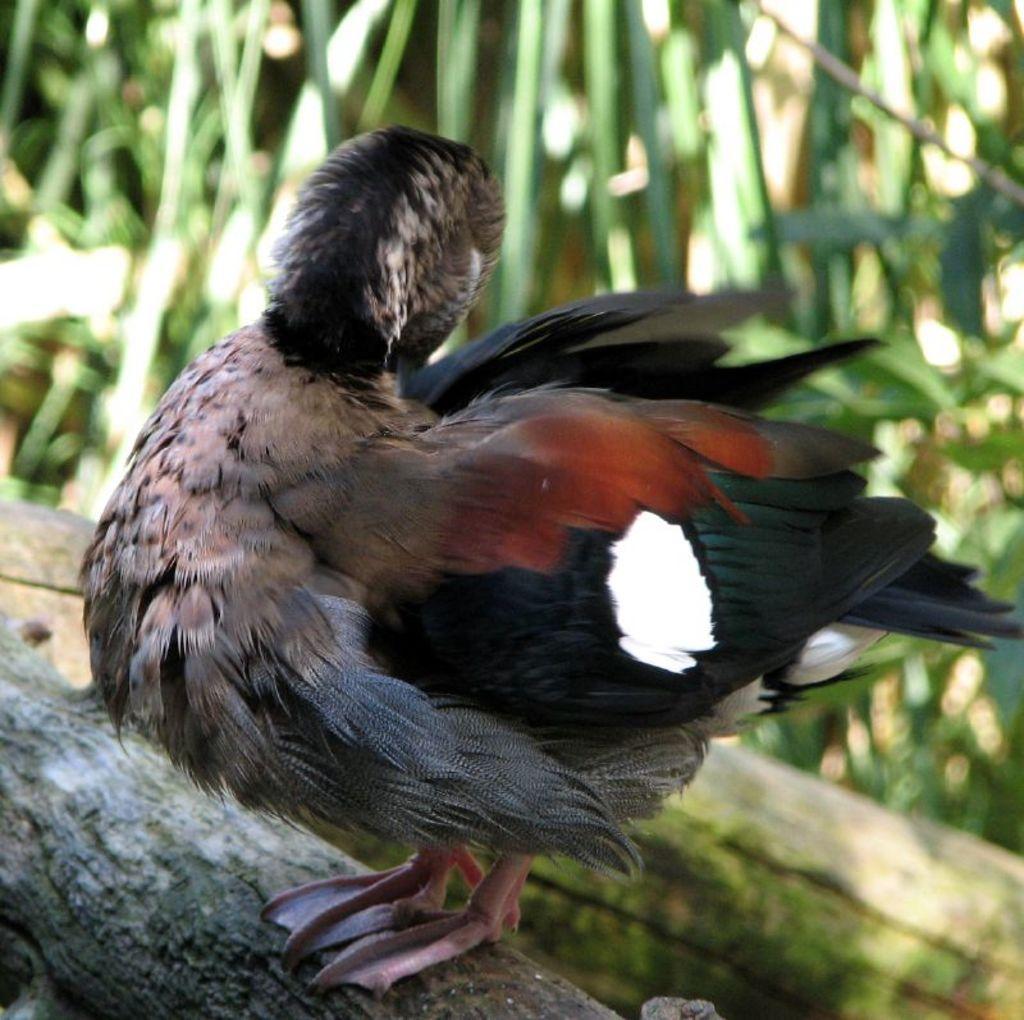In one or two sentences, can you explain what this image depicts? In this picture I can see a duck on the tree bark and I can see plants in the background. 